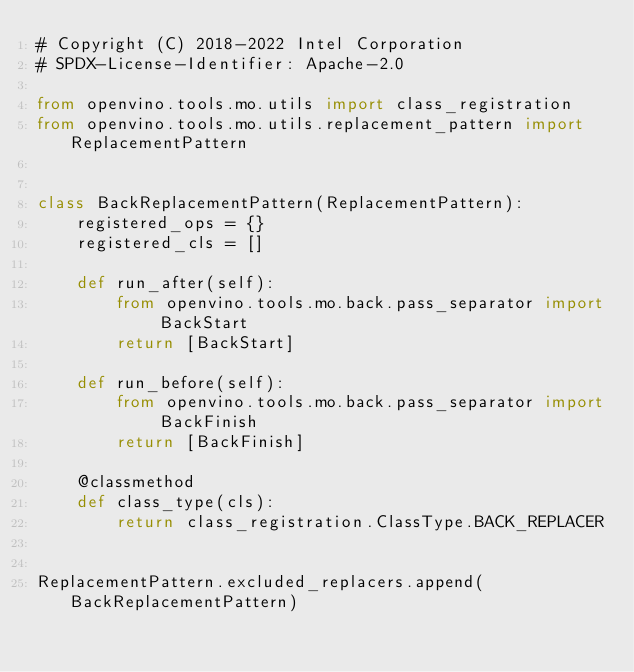<code> <loc_0><loc_0><loc_500><loc_500><_Python_># Copyright (C) 2018-2022 Intel Corporation
# SPDX-License-Identifier: Apache-2.0

from openvino.tools.mo.utils import class_registration
from openvino.tools.mo.utils.replacement_pattern import ReplacementPattern


class BackReplacementPattern(ReplacementPattern):
    registered_ops = {}
    registered_cls = []

    def run_after(self):
        from openvino.tools.mo.back.pass_separator import BackStart
        return [BackStart]

    def run_before(self):
        from openvino.tools.mo.back.pass_separator import BackFinish
        return [BackFinish]

    @classmethod
    def class_type(cls):
        return class_registration.ClassType.BACK_REPLACER


ReplacementPattern.excluded_replacers.append(BackReplacementPattern)
</code> 